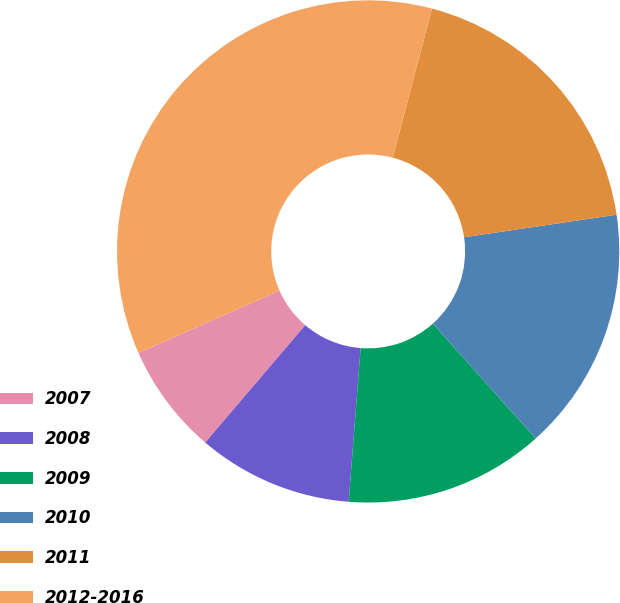Convert chart to OTSL. <chart><loc_0><loc_0><loc_500><loc_500><pie_chart><fcel>2007<fcel>2008<fcel>2009<fcel>2010<fcel>2011<fcel>2012-2016<nl><fcel>7.14%<fcel>10.0%<fcel>12.86%<fcel>15.71%<fcel>18.57%<fcel>35.71%<nl></chart> 